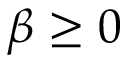<formula> <loc_0><loc_0><loc_500><loc_500>\beta \geq 0</formula> 